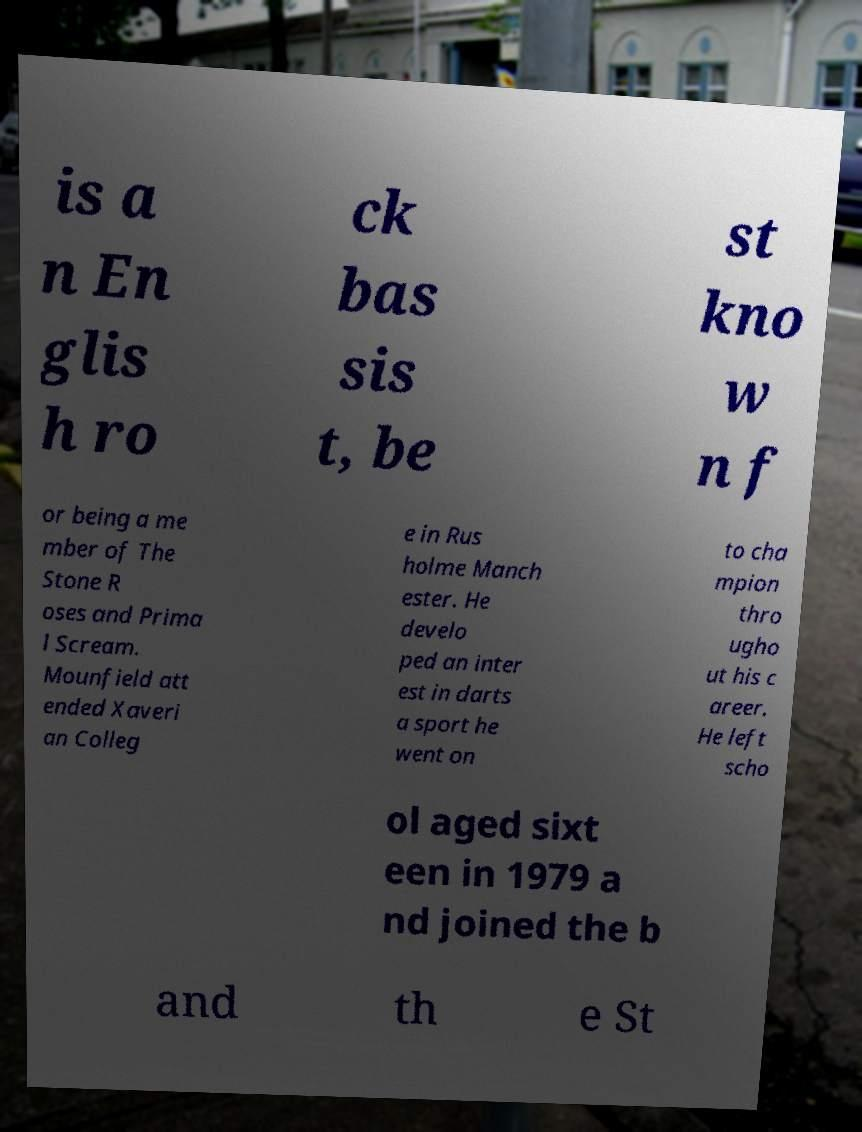There's text embedded in this image that I need extracted. Can you transcribe it verbatim? is a n En glis h ro ck bas sis t, be st kno w n f or being a me mber of The Stone R oses and Prima l Scream. Mounfield att ended Xaveri an Colleg e in Rus holme Manch ester. He develo ped an inter est in darts a sport he went on to cha mpion thro ugho ut his c areer. He left scho ol aged sixt een in 1979 a nd joined the b and th e St 